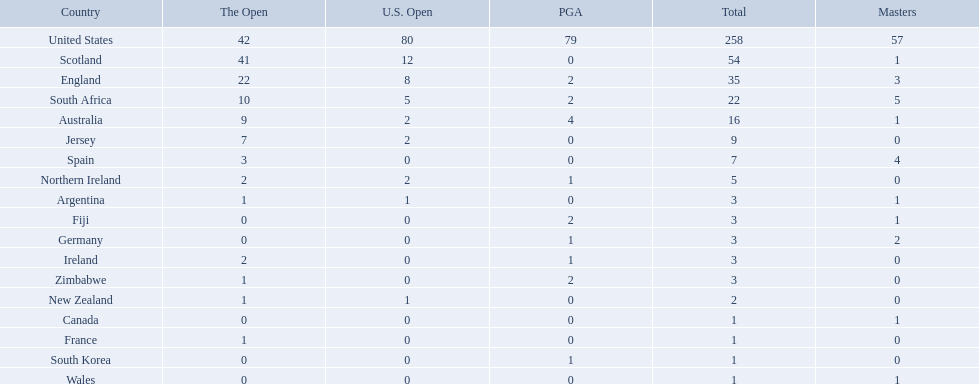Which of the countries listed are african? South Africa, Zimbabwe. Which of those has the least championship winning golfers? Zimbabwe. 